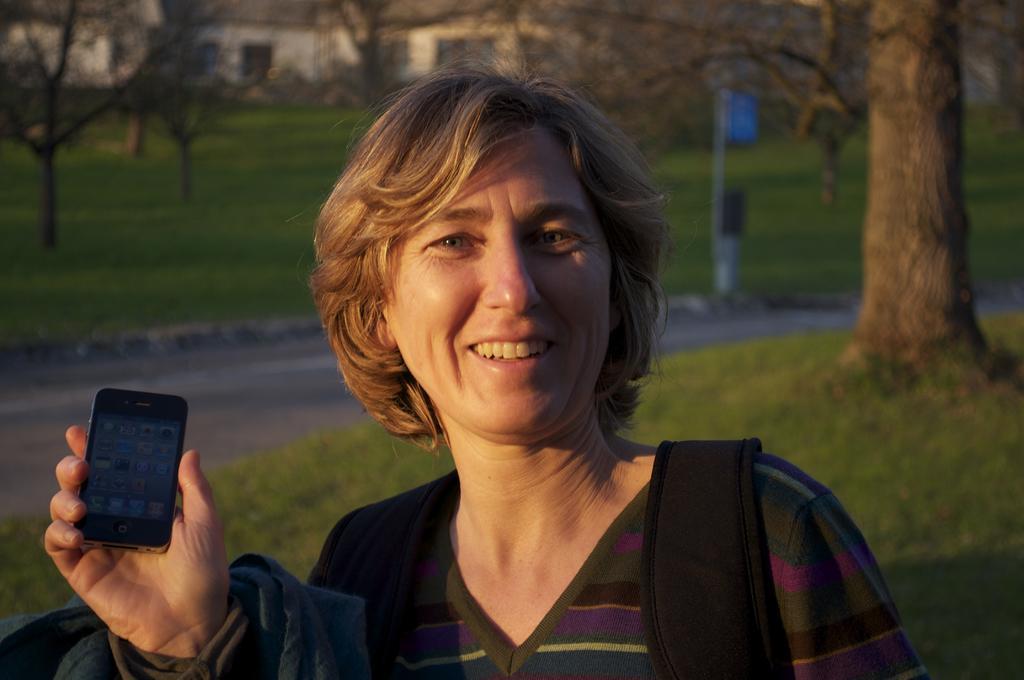Describe this image in one or two sentences. This woman is highlighted in this picture. This woman wore bag and holding a mobile. Grass is in green color. Far there are bare trees and building. 